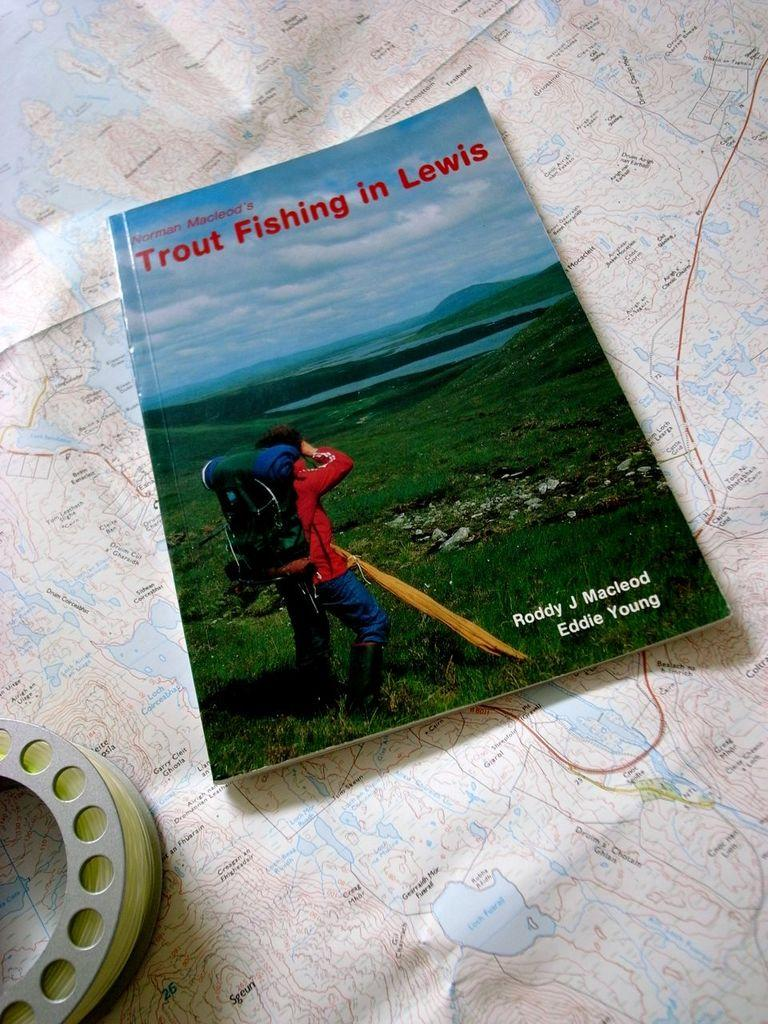<image>
Write a terse but informative summary of the picture. a book that talks about trout fishing in Lewis 